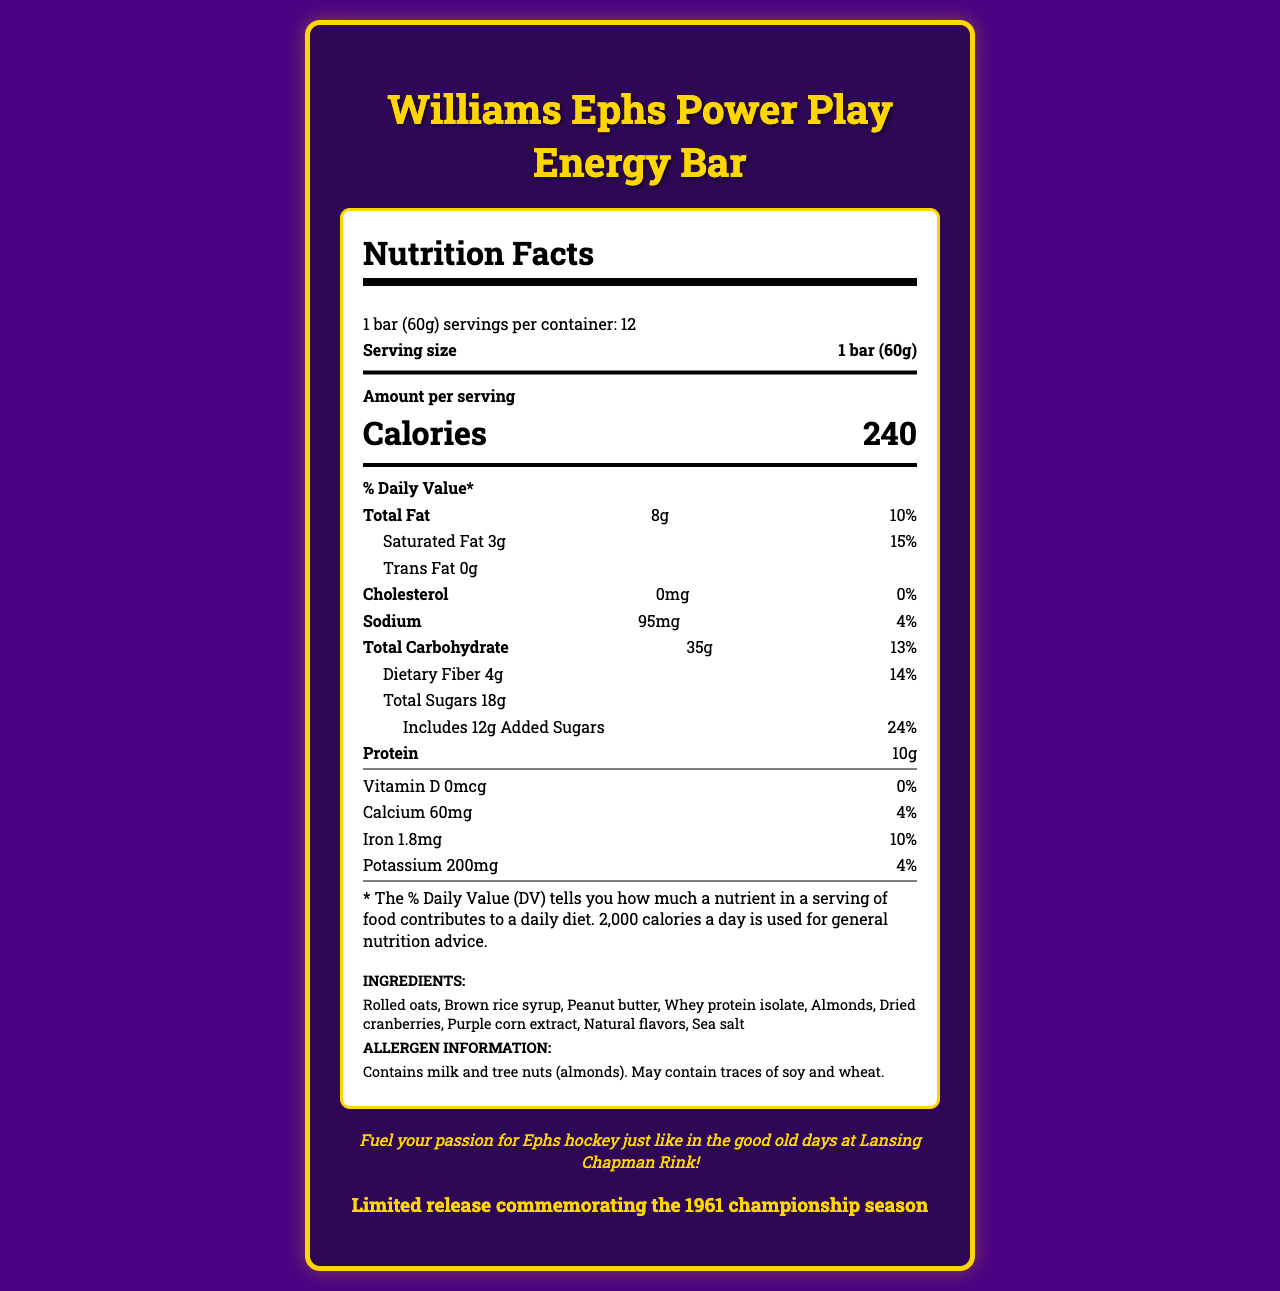what is the serving size of the Williams Ephs Power Play Energy Bar? The serving size is stated at the top of the nutrition label as "1 bar (60g)".
Answer: 1 bar (60g) how many calories are there per serving? The calories per serving are displayed prominently in a larger font within the nutrition label, indicating "Calories 240".
Answer: 240 what is the total fat content per serving? The total fat content per serving is listed in the nutrition facts section, showing "Total Fat: 8g".
Answer: 8g what ingredients are included in the energy bar? The ingredients are listed towards the bottom of the document under the "INGREDIENTS" section.
Answer: Rolled oats, Brown rice syrup, Peanut butter, Whey protein isolate, Almonds, Dried cranberries, Purple corn extract, Natural flavors, Sea salt what specific allergen information is provided? The allergen information is indicated below the ingredients section as "Contains milk and tree nuts (almonds). May contain traces of soy and wheat."
Answer: Contains milk and tree nuts (almonds). May contain traces of soy and wheat. how much sodium is in a serving? The sodium content per serving is listed in the nutrition facts section as "Sodium: 95mg".
Answer: 95mg what is the amount of protein per serving? The protein amount per serving is listed in the nutrition facts section as "Protein: 10g".
Answer: 10g what percentage of the daily recommended value of dietary fiber does one serving provide? The daily value percentage for dietary fiber per serving is shown in the nutrition facts section as "Dietary Fiber: 14% DV".
Answer: 14% how many servings are in each container? It is mentioned on the label, "12 servings per container".
Answer: 12 how many grams of saturated fat are there in each serving? The document lists the saturated fat content as "Saturated Fat: 3g".
Answer: 3g which nutrients are present with a daily value percentage of 4%? 
I. Sodium 
II. Calcium 
III. Potassium 
IV. Total Carbohydrate 
V. Iron Sodium (4%), Calcium (4%), and Potassium (4%) are the nutrients with a daily value of 4% listed in the nutrition facts section.
Answer: I, II, III which of the following features is NOT highlighted as a special feature of the energy bar? 
A. No artificial preservatives 
B. Good source of fiber 
C. Low sodium 
D. Purple and gold packaging inspired by Williams College colors The special features listed are "No artificial preservatives", "Good source of fiber", "Purple and gold packaging inspired by Williams College colors". "Low sodium" is not mentioned as a special feature.
Answer: C does the product contain any added sugars? The nutrition facts label includes "Includes 12g Added Sugars".
Answer: Yes describe the main idea of this document. The document serves to inform consumers about the nutritional content and ingredients of the energy bar while highlighting its connection to Williams College and the Ephs hockey team.
Answer: The document is a detailed nutrition facts label for the "Williams Ephs Power Play Energy Bar". It provides essential nutrition information per serving, including calories, fats, carbohydrates, proteins, vitamins, and minerals. It also lists the ingredients, allergen information, special features, and a nostalgic note connecting the product to the Williams Ephs hockey team. what is the price of the Williams Ephs Power Play Energy Bar? The document does not provide any information about the price of the energy bar.
Answer: Cannot be determined 